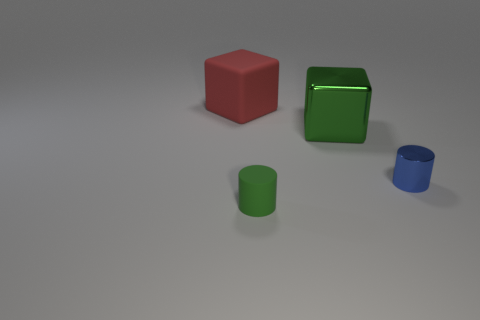What number of objects are both to the left of the big green metal object and in front of the big green metal thing?
Provide a short and direct response. 1. What number of other objects are there of the same color as the small rubber thing?
Keep it short and to the point. 1. What shape is the rubber thing behind the green matte thing?
Your response must be concise. Cube. Is the material of the large red cube the same as the green cylinder?
Give a very brief answer. Yes. There is a metallic cylinder; what number of tiny blue things are in front of it?
Make the answer very short. 0. What is the shape of the matte thing that is in front of the block that is behind the shiny cube?
Ensure brevity in your answer.  Cylinder. Is there any other thing that has the same shape as the green rubber thing?
Provide a succinct answer. Yes. Is the number of big blocks that are in front of the big matte object greater than the number of small red matte objects?
Your answer should be very brief. Yes. What number of red things are behind the cylinder that is left of the blue object?
Ensure brevity in your answer.  1. There is a green thing that is behind the green thing in front of the small object right of the big green object; what is its shape?
Your answer should be compact. Cube. 